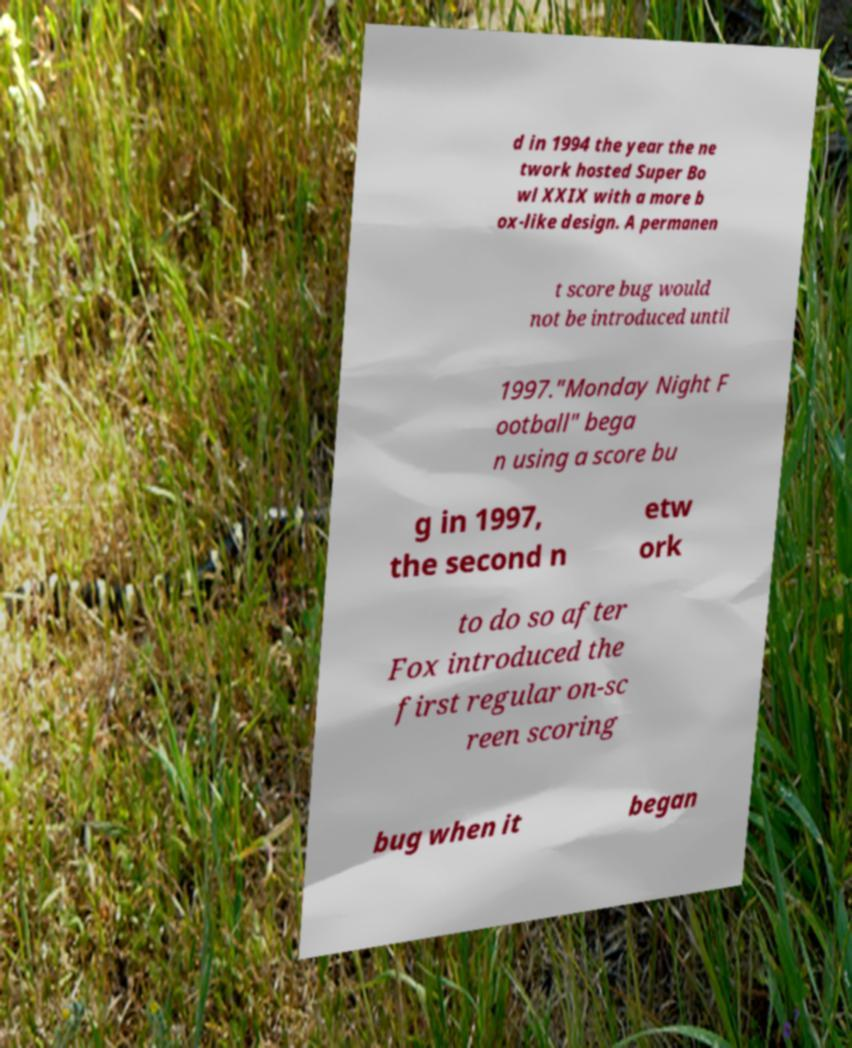For documentation purposes, I need the text within this image transcribed. Could you provide that? d in 1994 the year the ne twork hosted Super Bo wl XXIX with a more b ox-like design. A permanen t score bug would not be introduced until 1997."Monday Night F ootball" bega n using a score bu g in 1997, the second n etw ork to do so after Fox introduced the first regular on-sc reen scoring bug when it began 